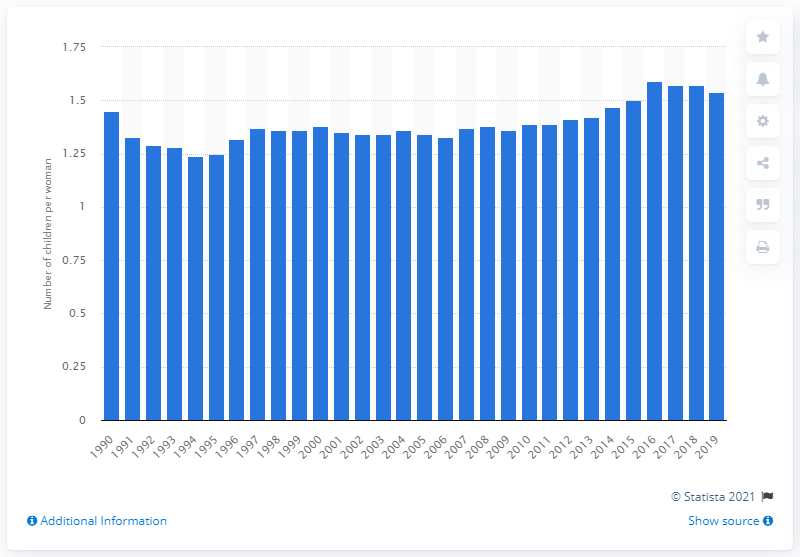Mention a couple of crucial points in this snapshot. In 2019, the average number of children per woman in Germany was 1.54. In 1990, the fertility rate was 1.45. 